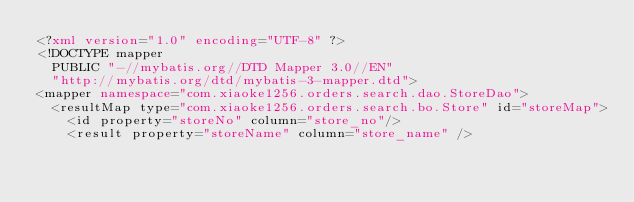Convert code to text. <code><loc_0><loc_0><loc_500><loc_500><_XML_><?xml version="1.0" encoding="UTF-8" ?>
<!DOCTYPE mapper
  PUBLIC "-//mybatis.org//DTD Mapper 3.0//EN"
  "http://mybatis.org/dtd/mybatis-3-mapper.dtd">
<mapper namespace="com.xiaoke1256.orders.search.dao.StoreDao">
	<resultMap type="com.xiaoke1256.orders.search.bo.Store" id="storeMap">
		<id property="storeNo" column="store_no"/>
		<result property="storeName" column="store_name" /></code> 